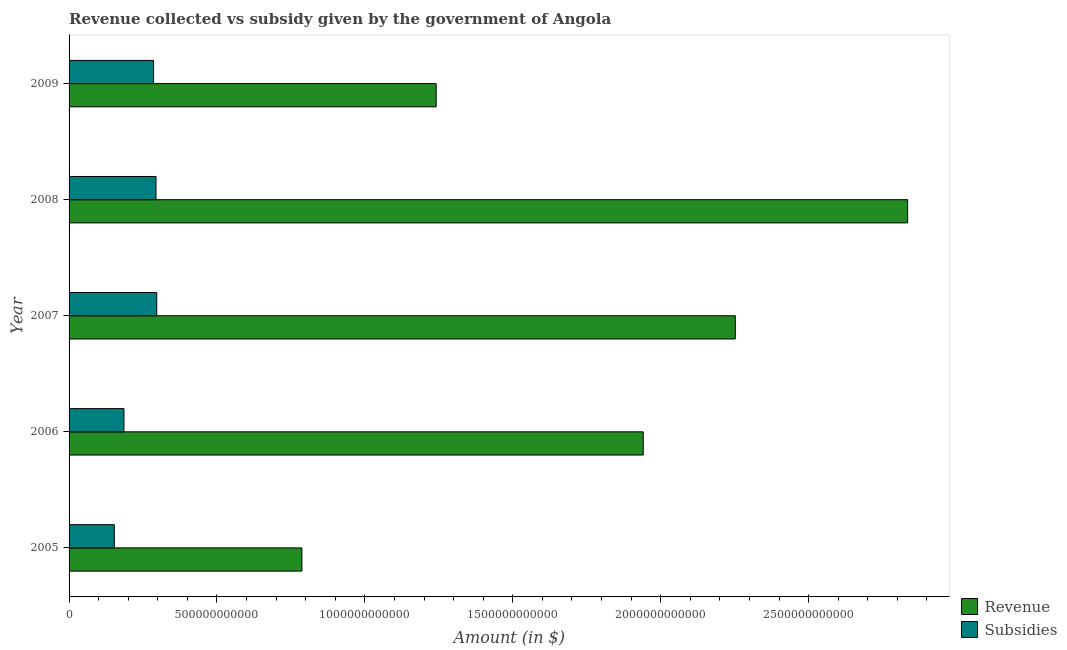How many bars are there on the 3rd tick from the top?
Keep it short and to the point. 2. What is the label of the 2nd group of bars from the top?
Keep it short and to the point. 2008. In how many cases, is the number of bars for a given year not equal to the number of legend labels?
Provide a short and direct response. 0. What is the amount of subsidies given in 2009?
Your answer should be compact. 2.86e+11. Across all years, what is the maximum amount of revenue collected?
Keep it short and to the point. 2.83e+12. Across all years, what is the minimum amount of revenue collected?
Offer a very short reply. 7.87e+11. In which year was the amount of revenue collected minimum?
Keep it short and to the point. 2005. What is the total amount of revenue collected in the graph?
Offer a very short reply. 9.06e+12. What is the difference between the amount of subsidies given in 2006 and that in 2007?
Keep it short and to the point. -1.11e+11. What is the difference between the amount of subsidies given in 2008 and the amount of revenue collected in 2005?
Your response must be concise. -4.93e+11. What is the average amount of subsidies given per year?
Provide a succinct answer. 2.43e+11. In the year 2007, what is the difference between the amount of revenue collected and amount of subsidies given?
Make the answer very short. 1.96e+12. What is the ratio of the amount of subsidies given in 2007 to that in 2009?
Keep it short and to the point. 1.04. Is the amount of subsidies given in 2008 less than that in 2009?
Keep it short and to the point. No. Is the difference between the amount of revenue collected in 2005 and 2006 greater than the difference between the amount of subsidies given in 2005 and 2006?
Ensure brevity in your answer.  No. What is the difference between the highest and the second highest amount of revenue collected?
Offer a terse response. 5.82e+11. What is the difference between the highest and the lowest amount of revenue collected?
Keep it short and to the point. 2.05e+12. In how many years, is the amount of revenue collected greater than the average amount of revenue collected taken over all years?
Provide a short and direct response. 3. What does the 2nd bar from the top in 2008 represents?
Provide a short and direct response. Revenue. What does the 1st bar from the bottom in 2006 represents?
Keep it short and to the point. Revenue. How many bars are there?
Make the answer very short. 10. Are all the bars in the graph horizontal?
Ensure brevity in your answer.  Yes. How many years are there in the graph?
Your response must be concise. 5. What is the difference between two consecutive major ticks on the X-axis?
Make the answer very short. 5.00e+11. Are the values on the major ticks of X-axis written in scientific E-notation?
Provide a succinct answer. No. Does the graph contain any zero values?
Your answer should be very brief. No. Does the graph contain grids?
Give a very brief answer. No. How many legend labels are there?
Your answer should be very brief. 2. How are the legend labels stacked?
Provide a short and direct response. Vertical. What is the title of the graph?
Keep it short and to the point. Revenue collected vs subsidy given by the government of Angola. Does "Goods" appear as one of the legend labels in the graph?
Your answer should be compact. No. What is the label or title of the X-axis?
Offer a terse response. Amount (in $). What is the label or title of the Y-axis?
Provide a short and direct response. Year. What is the Amount (in $) in Revenue in 2005?
Provide a succinct answer. 7.87e+11. What is the Amount (in $) of Subsidies in 2005?
Provide a succinct answer. 1.53e+11. What is the Amount (in $) of Revenue in 2006?
Ensure brevity in your answer.  1.94e+12. What is the Amount (in $) in Subsidies in 2006?
Your answer should be very brief. 1.86e+11. What is the Amount (in $) in Revenue in 2007?
Your answer should be very brief. 2.25e+12. What is the Amount (in $) in Subsidies in 2007?
Ensure brevity in your answer.  2.96e+11. What is the Amount (in $) in Revenue in 2008?
Offer a very short reply. 2.83e+12. What is the Amount (in $) of Subsidies in 2008?
Offer a terse response. 2.94e+11. What is the Amount (in $) in Revenue in 2009?
Provide a short and direct response. 1.24e+12. What is the Amount (in $) of Subsidies in 2009?
Offer a terse response. 2.86e+11. Across all years, what is the maximum Amount (in $) in Revenue?
Your answer should be very brief. 2.83e+12. Across all years, what is the maximum Amount (in $) of Subsidies?
Your answer should be very brief. 2.96e+11. Across all years, what is the minimum Amount (in $) in Revenue?
Provide a succinct answer. 7.87e+11. Across all years, what is the minimum Amount (in $) of Subsidies?
Your answer should be very brief. 1.53e+11. What is the total Amount (in $) in Revenue in the graph?
Your answer should be compact. 9.06e+12. What is the total Amount (in $) of Subsidies in the graph?
Provide a short and direct response. 1.21e+12. What is the difference between the Amount (in $) in Revenue in 2005 and that in 2006?
Your answer should be compact. -1.15e+12. What is the difference between the Amount (in $) of Subsidies in 2005 and that in 2006?
Your response must be concise. -3.26e+1. What is the difference between the Amount (in $) in Revenue in 2005 and that in 2007?
Your response must be concise. -1.47e+12. What is the difference between the Amount (in $) of Subsidies in 2005 and that in 2007?
Provide a succinct answer. -1.43e+11. What is the difference between the Amount (in $) of Revenue in 2005 and that in 2008?
Provide a short and direct response. -2.05e+12. What is the difference between the Amount (in $) of Subsidies in 2005 and that in 2008?
Provide a short and direct response. -1.41e+11. What is the difference between the Amount (in $) of Revenue in 2005 and that in 2009?
Provide a succinct answer. -4.54e+11. What is the difference between the Amount (in $) of Subsidies in 2005 and that in 2009?
Your answer should be very brief. -1.33e+11. What is the difference between the Amount (in $) in Revenue in 2006 and that in 2007?
Offer a very short reply. -3.11e+11. What is the difference between the Amount (in $) in Subsidies in 2006 and that in 2007?
Keep it short and to the point. -1.11e+11. What is the difference between the Amount (in $) of Revenue in 2006 and that in 2008?
Keep it short and to the point. -8.94e+11. What is the difference between the Amount (in $) of Subsidies in 2006 and that in 2008?
Provide a short and direct response. -1.08e+11. What is the difference between the Amount (in $) in Revenue in 2006 and that in 2009?
Ensure brevity in your answer.  7.00e+11. What is the difference between the Amount (in $) in Subsidies in 2006 and that in 2009?
Offer a terse response. -1.00e+11. What is the difference between the Amount (in $) of Revenue in 2007 and that in 2008?
Give a very brief answer. -5.82e+11. What is the difference between the Amount (in $) of Subsidies in 2007 and that in 2008?
Offer a very short reply. 2.50e+09. What is the difference between the Amount (in $) of Revenue in 2007 and that in 2009?
Make the answer very short. 1.01e+12. What is the difference between the Amount (in $) in Subsidies in 2007 and that in 2009?
Keep it short and to the point. 1.06e+1. What is the difference between the Amount (in $) of Revenue in 2008 and that in 2009?
Offer a very short reply. 1.59e+12. What is the difference between the Amount (in $) of Subsidies in 2008 and that in 2009?
Provide a short and direct response. 8.11e+09. What is the difference between the Amount (in $) of Revenue in 2005 and the Amount (in $) of Subsidies in 2006?
Ensure brevity in your answer.  6.01e+11. What is the difference between the Amount (in $) of Revenue in 2005 and the Amount (in $) of Subsidies in 2007?
Ensure brevity in your answer.  4.91e+11. What is the difference between the Amount (in $) of Revenue in 2005 and the Amount (in $) of Subsidies in 2008?
Give a very brief answer. 4.93e+11. What is the difference between the Amount (in $) in Revenue in 2005 and the Amount (in $) in Subsidies in 2009?
Make the answer very short. 5.01e+11. What is the difference between the Amount (in $) of Revenue in 2006 and the Amount (in $) of Subsidies in 2007?
Provide a short and direct response. 1.64e+12. What is the difference between the Amount (in $) in Revenue in 2006 and the Amount (in $) in Subsidies in 2008?
Your response must be concise. 1.65e+12. What is the difference between the Amount (in $) of Revenue in 2006 and the Amount (in $) of Subsidies in 2009?
Give a very brief answer. 1.66e+12. What is the difference between the Amount (in $) in Revenue in 2007 and the Amount (in $) in Subsidies in 2008?
Offer a terse response. 1.96e+12. What is the difference between the Amount (in $) of Revenue in 2007 and the Amount (in $) of Subsidies in 2009?
Provide a succinct answer. 1.97e+12. What is the difference between the Amount (in $) of Revenue in 2008 and the Amount (in $) of Subsidies in 2009?
Keep it short and to the point. 2.55e+12. What is the average Amount (in $) in Revenue per year?
Provide a succinct answer. 1.81e+12. What is the average Amount (in $) of Subsidies per year?
Your answer should be very brief. 2.43e+11. In the year 2005, what is the difference between the Amount (in $) in Revenue and Amount (in $) in Subsidies?
Give a very brief answer. 6.34e+11. In the year 2006, what is the difference between the Amount (in $) in Revenue and Amount (in $) in Subsidies?
Your answer should be compact. 1.76e+12. In the year 2007, what is the difference between the Amount (in $) in Revenue and Amount (in $) in Subsidies?
Keep it short and to the point. 1.96e+12. In the year 2008, what is the difference between the Amount (in $) of Revenue and Amount (in $) of Subsidies?
Your response must be concise. 2.54e+12. In the year 2009, what is the difference between the Amount (in $) in Revenue and Amount (in $) in Subsidies?
Your answer should be compact. 9.55e+11. What is the ratio of the Amount (in $) of Revenue in 2005 to that in 2006?
Provide a succinct answer. 0.41. What is the ratio of the Amount (in $) of Subsidies in 2005 to that in 2006?
Provide a succinct answer. 0.82. What is the ratio of the Amount (in $) in Revenue in 2005 to that in 2007?
Your response must be concise. 0.35. What is the ratio of the Amount (in $) in Subsidies in 2005 to that in 2007?
Offer a very short reply. 0.52. What is the ratio of the Amount (in $) in Revenue in 2005 to that in 2008?
Give a very brief answer. 0.28. What is the ratio of the Amount (in $) in Subsidies in 2005 to that in 2008?
Your answer should be very brief. 0.52. What is the ratio of the Amount (in $) of Revenue in 2005 to that in 2009?
Provide a short and direct response. 0.63. What is the ratio of the Amount (in $) of Subsidies in 2005 to that in 2009?
Your answer should be compact. 0.54. What is the ratio of the Amount (in $) of Revenue in 2006 to that in 2007?
Provide a short and direct response. 0.86. What is the ratio of the Amount (in $) in Subsidies in 2006 to that in 2007?
Give a very brief answer. 0.63. What is the ratio of the Amount (in $) in Revenue in 2006 to that in 2008?
Give a very brief answer. 0.68. What is the ratio of the Amount (in $) in Subsidies in 2006 to that in 2008?
Offer a terse response. 0.63. What is the ratio of the Amount (in $) in Revenue in 2006 to that in 2009?
Ensure brevity in your answer.  1.56. What is the ratio of the Amount (in $) of Subsidies in 2006 to that in 2009?
Keep it short and to the point. 0.65. What is the ratio of the Amount (in $) of Revenue in 2007 to that in 2008?
Give a very brief answer. 0.79. What is the ratio of the Amount (in $) in Subsidies in 2007 to that in 2008?
Ensure brevity in your answer.  1.01. What is the ratio of the Amount (in $) in Revenue in 2007 to that in 2009?
Your response must be concise. 1.81. What is the ratio of the Amount (in $) in Subsidies in 2007 to that in 2009?
Provide a short and direct response. 1.04. What is the ratio of the Amount (in $) in Revenue in 2008 to that in 2009?
Offer a very short reply. 2.28. What is the ratio of the Amount (in $) in Subsidies in 2008 to that in 2009?
Offer a very short reply. 1.03. What is the difference between the highest and the second highest Amount (in $) in Revenue?
Make the answer very short. 5.82e+11. What is the difference between the highest and the second highest Amount (in $) of Subsidies?
Your answer should be very brief. 2.50e+09. What is the difference between the highest and the lowest Amount (in $) in Revenue?
Provide a short and direct response. 2.05e+12. What is the difference between the highest and the lowest Amount (in $) in Subsidies?
Offer a very short reply. 1.43e+11. 